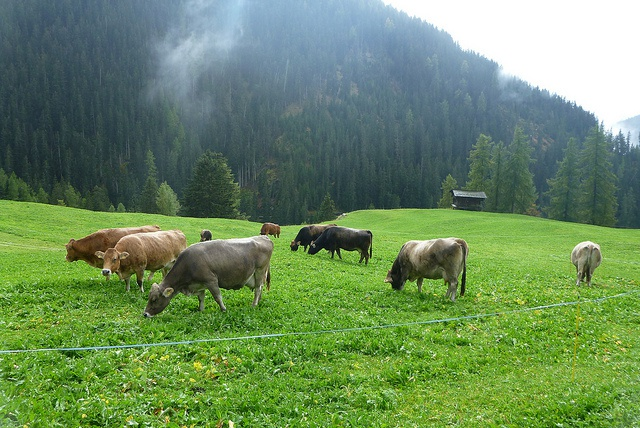Describe the objects in this image and their specific colors. I can see cow in teal, gray, black, darkgreen, and darkgray tones, cow in teal, black, darkgreen, gray, and olive tones, cow in teal, olive, tan, gray, and black tones, cow in teal, black, gray, and darkgreen tones, and cow in teal, maroon, black, and gray tones in this image. 